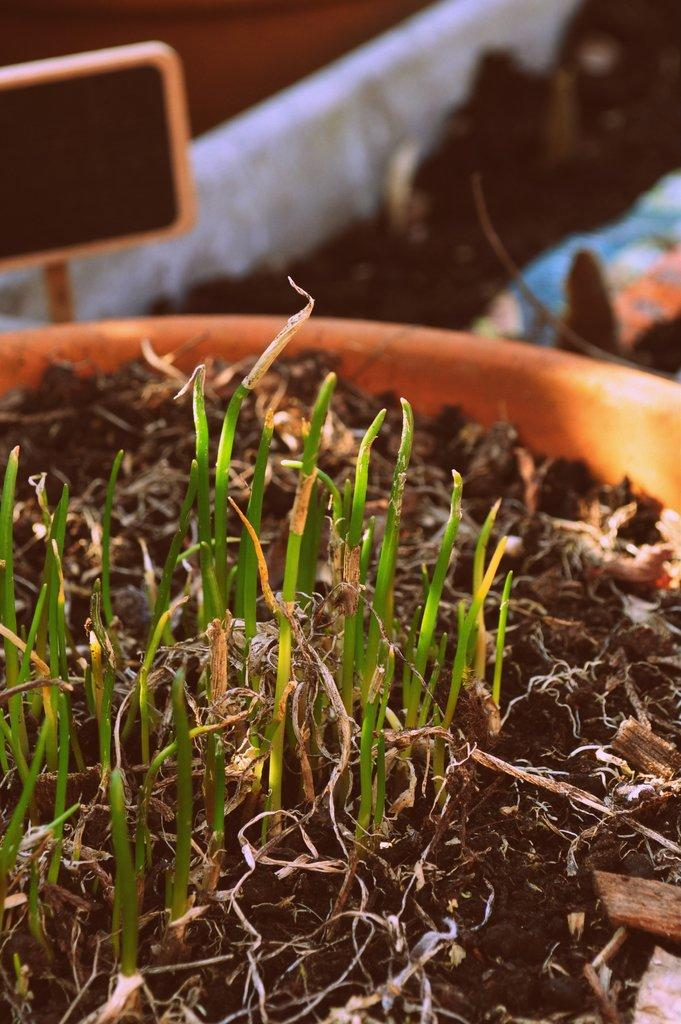What is in the pot that is visible in the image? There is a pot with mud in the image. What is growing in the mud? There are grass sprouts in the mud. Can you describe the area around the pot? There may be more mud beside the pot. What type of chairs can be seen in the image? There are no chairs present in the image; it features a pot with mud and grass sprouts. What drink is being served in the image? There is no drink present in the image; it features a pot with mud and grass sprouts. 